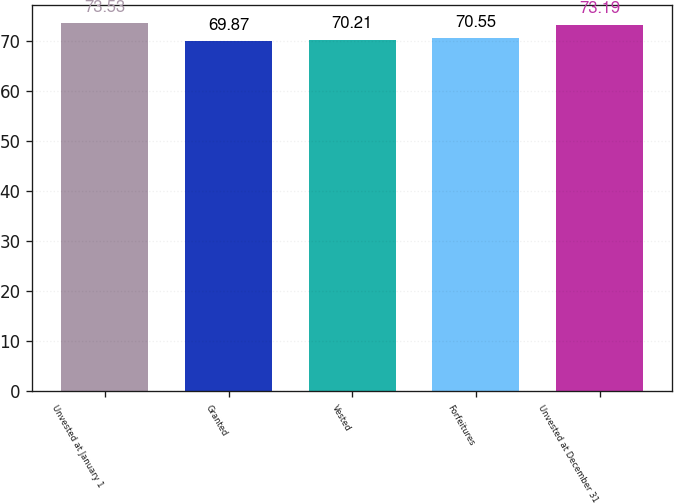Convert chart to OTSL. <chart><loc_0><loc_0><loc_500><loc_500><bar_chart><fcel>Unvested at January 1<fcel>Granted<fcel>Vested<fcel>Forfeitures<fcel>Unvested at December 31<nl><fcel>73.53<fcel>69.87<fcel>70.21<fcel>70.55<fcel>73.19<nl></chart> 